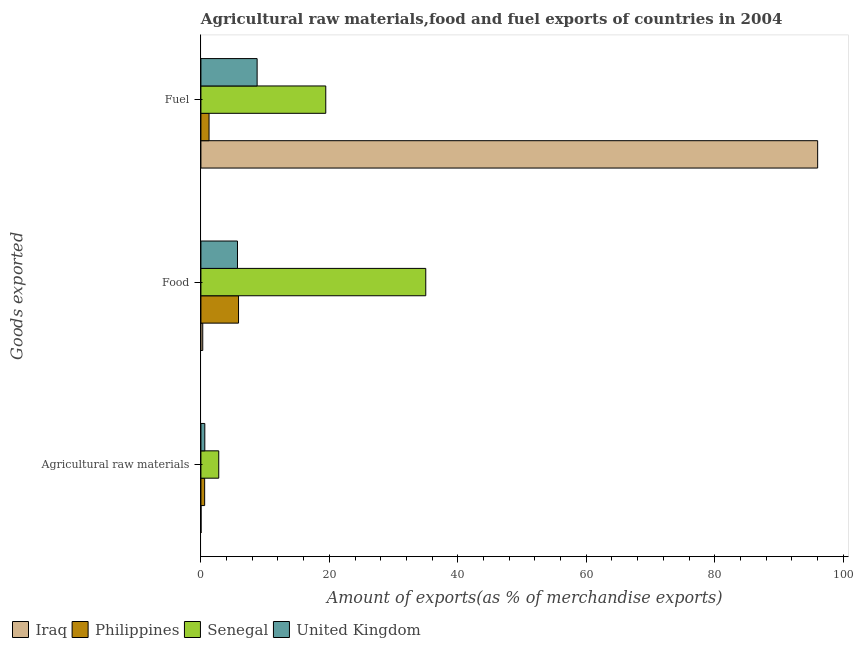How many different coloured bars are there?
Ensure brevity in your answer.  4. How many groups of bars are there?
Ensure brevity in your answer.  3. Are the number of bars per tick equal to the number of legend labels?
Your answer should be very brief. Yes. Are the number of bars on each tick of the Y-axis equal?
Offer a terse response. Yes. How many bars are there on the 3rd tick from the top?
Your answer should be very brief. 4. What is the label of the 1st group of bars from the top?
Your answer should be very brief. Fuel. What is the percentage of raw materials exports in Senegal?
Your answer should be compact. 2.78. Across all countries, what is the maximum percentage of fuel exports?
Keep it short and to the point. 96.03. Across all countries, what is the minimum percentage of raw materials exports?
Keep it short and to the point. 0.01. In which country was the percentage of fuel exports maximum?
Provide a succinct answer. Iraq. In which country was the percentage of food exports minimum?
Provide a succinct answer. Iraq. What is the total percentage of fuel exports in the graph?
Provide a succinct answer. 125.49. What is the difference between the percentage of food exports in Iraq and that in Philippines?
Provide a succinct answer. -5.57. What is the difference between the percentage of food exports in Senegal and the percentage of fuel exports in Iraq?
Ensure brevity in your answer.  -61.02. What is the average percentage of food exports per country?
Offer a very short reply. 11.71. What is the difference between the percentage of raw materials exports and percentage of food exports in Senegal?
Provide a succinct answer. -32.23. In how many countries, is the percentage of raw materials exports greater than 32 %?
Offer a very short reply. 0. What is the ratio of the percentage of raw materials exports in United Kingdom to that in Philippines?
Offer a terse response. 1.04. What is the difference between the highest and the second highest percentage of food exports?
Give a very brief answer. 29.15. What is the difference between the highest and the lowest percentage of raw materials exports?
Your answer should be very brief. 2.76. What does the 2nd bar from the top in Food represents?
Ensure brevity in your answer.  Senegal. Are all the bars in the graph horizontal?
Offer a very short reply. Yes. What is the difference between two consecutive major ticks on the X-axis?
Ensure brevity in your answer.  20. Are the values on the major ticks of X-axis written in scientific E-notation?
Offer a terse response. No. Does the graph contain any zero values?
Make the answer very short. No. Where does the legend appear in the graph?
Your response must be concise. Bottom left. How many legend labels are there?
Give a very brief answer. 4. What is the title of the graph?
Offer a very short reply. Agricultural raw materials,food and fuel exports of countries in 2004. Does "Puerto Rico" appear as one of the legend labels in the graph?
Offer a terse response. No. What is the label or title of the X-axis?
Ensure brevity in your answer.  Amount of exports(as % of merchandise exports). What is the label or title of the Y-axis?
Your answer should be compact. Goods exported. What is the Amount of exports(as % of merchandise exports) of Iraq in Agricultural raw materials?
Ensure brevity in your answer.  0.01. What is the Amount of exports(as % of merchandise exports) of Philippines in Agricultural raw materials?
Your response must be concise. 0.58. What is the Amount of exports(as % of merchandise exports) in Senegal in Agricultural raw materials?
Your answer should be compact. 2.78. What is the Amount of exports(as % of merchandise exports) in United Kingdom in Agricultural raw materials?
Provide a short and direct response. 0.61. What is the Amount of exports(as % of merchandise exports) of Iraq in Food?
Provide a succinct answer. 0.29. What is the Amount of exports(as % of merchandise exports) of Philippines in Food?
Give a very brief answer. 5.86. What is the Amount of exports(as % of merchandise exports) in Senegal in Food?
Offer a terse response. 35.01. What is the Amount of exports(as % of merchandise exports) of United Kingdom in Food?
Provide a succinct answer. 5.69. What is the Amount of exports(as % of merchandise exports) of Iraq in Fuel?
Ensure brevity in your answer.  96.03. What is the Amount of exports(as % of merchandise exports) of Philippines in Fuel?
Give a very brief answer. 1.26. What is the Amount of exports(as % of merchandise exports) in Senegal in Fuel?
Offer a very short reply. 19.44. What is the Amount of exports(as % of merchandise exports) in United Kingdom in Fuel?
Offer a terse response. 8.75. Across all Goods exported, what is the maximum Amount of exports(as % of merchandise exports) in Iraq?
Provide a succinct answer. 96.03. Across all Goods exported, what is the maximum Amount of exports(as % of merchandise exports) in Philippines?
Provide a succinct answer. 5.86. Across all Goods exported, what is the maximum Amount of exports(as % of merchandise exports) in Senegal?
Your response must be concise. 35.01. Across all Goods exported, what is the maximum Amount of exports(as % of merchandise exports) in United Kingdom?
Provide a succinct answer. 8.75. Across all Goods exported, what is the minimum Amount of exports(as % of merchandise exports) of Iraq?
Offer a very short reply. 0.01. Across all Goods exported, what is the minimum Amount of exports(as % of merchandise exports) of Philippines?
Make the answer very short. 0.58. Across all Goods exported, what is the minimum Amount of exports(as % of merchandise exports) of Senegal?
Offer a very short reply. 2.78. Across all Goods exported, what is the minimum Amount of exports(as % of merchandise exports) in United Kingdom?
Your answer should be compact. 0.61. What is the total Amount of exports(as % of merchandise exports) in Iraq in the graph?
Your answer should be very brief. 96.33. What is the total Amount of exports(as % of merchandise exports) of Philippines in the graph?
Provide a short and direct response. 7.7. What is the total Amount of exports(as % of merchandise exports) of Senegal in the graph?
Give a very brief answer. 57.23. What is the total Amount of exports(as % of merchandise exports) in United Kingdom in the graph?
Offer a terse response. 15.05. What is the difference between the Amount of exports(as % of merchandise exports) in Iraq in Agricultural raw materials and that in Food?
Offer a very short reply. -0.27. What is the difference between the Amount of exports(as % of merchandise exports) of Philippines in Agricultural raw materials and that in Food?
Offer a terse response. -5.27. What is the difference between the Amount of exports(as % of merchandise exports) in Senegal in Agricultural raw materials and that in Food?
Your answer should be very brief. -32.23. What is the difference between the Amount of exports(as % of merchandise exports) in United Kingdom in Agricultural raw materials and that in Food?
Your answer should be compact. -5.09. What is the difference between the Amount of exports(as % of merchandise exports) of Iraq in Agricultural raw materials and that in Fuel?
Provide a succinct answer. -96.02. What is the difference between the Amount of exports(as % of merchandise exports) of Philippines in Agricultural raw materials and that in Fuel?
Keep it short and to the point. -0.68. What is the difference between the Amount of exports(as % of merchandise exports) of Senegal in Agricultural raw materials and that in Fuel?
Give a very brief answer. -16.66. What is the difference between the Amount of exports(as % of merchandise exports) of United Kingdom in Agricultural raw materials and that in Fuel?
Provide a short and direct response. -8.15. What is the difference between the Amount of exports(as % of merchandise exports) of Iraq in Food and that in Fuel?
Provide a succinct answer. -95.75. What is the difference between the Amount of exports(as % of merchandise exports) of Philippines in Food and that in Fuel?
Provide a short and direct response. 4.59. What is the difference between the Amount of exports(as % of merchandise exports) in Senegal in Food and that in Fuel?
Keep it short and to the point. 15.57. What is the difference between the Amount of exports(as % of merchandise exports) of United Kingdom in Food and that in Fuel?
Ensure brevity in your answer.  -3.06. What is the difference between the Amount of exports(as % of merchandise exports) of Iraq in Agricultural raw materials and the Amount of exports(as % of merchandise exports) of Philippines in Food?
Provide a succinct answer. -5.84. What is the difference between the Amount of exports(as % of merchandise exports) of Iraq in Agricultural raw materials and the Amount of exports(as % of merchandise exports) of Senegal in Food?
Your answer should be very brief. -35. What is the difference between the Amount of exports(as % of merchandise exports) in Iraq in Agricultural raw materials and the Amount of exports(as % of merchandise exports) in United Kingdom in Food?
Your response must be concise. -5.68. What is the difference between the Amount of exports(as % of merchandise exports) of Philippines in Agricultural raw materials and the Amount of exports(as % of merchandise exports) of Senegal in Food?
Your answer should be very brief. -34.43. What is the difference between the Amount of exports(as % of merchandise exports) of Philippines in Agricultural raw materials and the Amount of exports(as % of merchandise exports) of United Kingdom in Food?
Your response must be concise. -5.11. What is the difference between the Amount of exports(as % of merchandise exports) of Senegal in Agricultural raw materials and the Amount of exports(as % of merchandise exports) of United Kingdom in Food?
Your response must be concise. -2.92. What is the difference between the Amount of exports(as % of merchandise exports) in Iraq in Agricultural raw materials and the Amount of exports(as % of merchandise exports) in Philippines in Fuel?
Provide a succinct answer. -1.25. What is the difference between the Amount of exports(as % of merchandise exports) of Iraq in Agricultural raw materials and the Amount of exports(as % of merchandise exports) of Senegal in Fuel?
Provide a short and direct response. -19.43. What is the difference between the Amount of exports(as % of merchandise exports) of Iraq in Agricultural raw materials and the Amount of exports(as % of merchandise exports) of United Kingdom in Fuel?
Make the answer very short. -8.74. What is the difference between the Amount of exports(as % of merchandise exports) in Philippines in Agricultural raw materials and the Amount of exports(as % of merchandise exports) in Senegal in Fuel?
Your answer should be very brief. -18.86. What is the difference between the Amount of exports(as % of merchandise exports) of Philippines in Agricultural raw materials and the Amount of exports(as % of merchandise exports) of United Kingdom in Fuel?
Offer a very short reply. -8.17. What is the difference between the Amount of exports(as % of merchandise exports) of Senegal in Agricultural raw materials and the Amount of exports(as % of merchandise exports) of United Kingdom in Fuel?
Your response must be concise. -5.98. What is the difference between the Amount of exports(as % of merchandise exports) of Iraq in Food and the Amount of exports(as % of merchandise exports) of Philippines in Fuel?
Keep it short and to the point. -0.98. What is the difference between the Amount of exports(as % of merchandise exports) in Iraq in Food and the Amount of exports(as % of merchandise exports) in Senegal in Fuel?
Your answer should be compact. -19.16. What is the difference between the Amount of exports(as % of merchandise exports) in Iraq in Food and the Amount of exports(as % of merchandise exports) in United Kingdom in Fuel?
Give a very brief answer. -8.47. What is the difference between the Amount of exports(as % of merchandise exports) of Philippines in Food and the Amount of exports(as % of merchandise exports) of Senegal in Fuel?
Offer a very short reply. -13.58. What is the difference between the Amount of exports(as % of merchandise exports) in Philippines in Food and the Amount of exports(as % of merchandise exports) in United Kingdom in Fuel?
Your answer should be very brief. -2.9. What is the difference between the Amount of exports(as % of merchandise exports) in Senegal in Food and the Amount of exports(as % of merchandise exports) in United Kingdom in Fuel?
Make the answer very short. 26.26. What is the average Amount of exports(as % of merchandise exports) of Iraq per Goods exported?
Ensure brevity in your answer.  32.11. What is the average Amount of exports(as % of merchandise exports) in Philippines per Goods exported?
Your answer should be very brief. 2.57. What is the average Amount of exports(as % of merchandise exports) in Senegal per Goods exported?
Your answer should be very brief. 19.08. What is the average Amount of exports(as % of merchandise exports) of United Kingdom per Goods exported?
Ensure brevity in your answer.  5.02. What is the difference between the Amount of exports(as % of merchandise exports) in Iraq and Amount of exports(as % of merchandise exports) in Philippines in Agricultural raw materials?
Ensure brevity in your answer.  -0.57. What is the difference between the Amount of exports(as % of merchandise exports) of Iraq and Amount of exports(as % of merchandise exports) of Senegal in Agricultural raw materials?
Your answer should be very brief. -2.76. What is the difference between the Amount of exports(as % of merchandise exports) of Iraq and Amount of exports(as % of merchandise exports) of United Kingdom in Agricultural raw materials?
Your response must be concise. -0.59. What is the difference between the Amount of exports(as % of merchandise exports) of Philippines and Amount of exports(as % of merchandise exports) of Senegal in Agricultural raw materials?
Make the answer very short. -2.19. What is the difference between the Amount of exports(as % of merchandise exports) in Philippines and Amount of exports(as % of merchandise exports) in United Kingdom in Agricultural raw materials?
Offer a terse response. -0.02. What is the difference between the Amount of exports(as % of merchandise exports) of Senegal and Amount of exports(as % of merchandise exports) of United Kingdom in Agricultural raw materials?
Your answer should be compact. 2.17. What is the difference between the Amount of exports(as % of merchandise exports) of Iraq and Amount of exports(as % of merchandise exports) of Philippines in Food?
Offer a terse response. -5.57. What is the difference between the Amount of exports(as % of merchandise exports) in Iraq and Amount of exports(as % of merchandise exports) in Senegal in Food?
Offer a terse response. -34.73. What is the difference between the Amount of exports(as % of merchandise exports) of Iraq and Amount of exports(as % of merchandise exports) of United Kingdom in Food?
Ensure brevity in your answer.  -5.41. What is the difference between the Amount of exports(as % of merchandise exports) in Philippines and Amount of exports(as % of merchandise exports) in Senegal in Food?
Offer a terse response. -29.15. What is the difference between the Amount of exports(as % of merchandise exports) of Philippines and Amount of exports(as % of merchandise exports) of United Kingdom in Food?
Give a very brief answer. 0.16. What is the difference between the Amount of exports(as % of merchandise exports) in Senegal and Amount of exports(as % of merchandise exports) in United Kingdom in Food?
Offer a terse response. 29.32. What is the difference between the Amount of exports(as % of merchandise exports) in Iraq and Amount of exports(as % of merchandise exports) in Philippines in Fuel?
Give a very brief answer. 94.77. What is the difference between the Amount of exports(as % of merchandise exports) in Iraq and Amount of exports(as % of merchandise exports) in Senegal in Fuel?
Your response must be concise. 76.59. What is the difference between the Amount of exports(as % of merchandise exports) in Iraq and Amount of exports(as % of merchandise exports) in United Kingdom in Fuel?
Your answer should be very brief. 87.28. What is the difference between the Amount of exports(as % of merchandise exports) in Philippines and Amount of exports(as % of merchandise exports) in Senegal in Fuel?
Provide a succinct answer. -18.18. What is the difference between the Amount of exports(as % of merchandise exports) in Philippines and Amount of exports(as % of merchandise exports) in United Kingdom in Fuel?
Keep it short and to the point. -7.49. What is the difference between the Amount of exports(as % of merchandise exports) in Senegal and Amount of exports(as % of merchandise exports) in United Kingdom in Fuel?
Offer a terse response. 10.69. What is the ratio of the Amount of exports(as % of merchandise exports) in Iraq in Agricultural raw materials to that in Food?
Make the answer very short. 0.05. What is the ratio of the Amount of exports(as % of merchandise exports) of Philippines in Agricultural raw materials to that in Food?
Your answer should be compact. 0.1. What is the ratio of the Amount of exports(as % of merchandise exports) of Senegal in Agricultural raw materials to that in Food?
Keep it short and to the point. 0.08. What is the ratio of the Amount of exports(as % of merchandise exports) of United Kingdom in Agricultural raw materials to that in Food?
Provide a short and direct response. 0.11. What is the ratio of the Amount of exports(as % of merchandise exports) in Philippines in Agricultural raw materials to that in Fuel?
Make the answer very short. 0.46. What is the ratio of the Amount of exports(as % of merchandise exports) of Senegal in Agricultural raw materials to that in Fuel?
Your answer should be compact. 0.14. What is the ratio of the Amount of exports(as % of merchandise exports) in United Kingdom in Agricultural raw materials to that in Fuel?
Your response must be concise. 0.07. What is the ratio of the Amount of exports(as % of merchandise exports) of Iraq in Food to that in Fuel?
Your answer should be very brief. 0. What is the ratio of the Amount of exports(as % of merchandise exports) of Philippines in Food to that in Fuel?
Your response must be concise. 4.63. What is the ratio of the Amount of exports(as % of merchandise exports) of Senegal in Food to that in Fuel?
Offer a terse response. 1.8. What is the ratio of the Amount of exports(as % of merchandise exports) in United Kingdom in Food to that in Fuel?
Keep it short and to the point. 0.65. What is the difference between the highest and the second highest Amount of exports(as % of merchandise exports) of Iraq?
Your answer should be very brief. 95.75. What is the difference between the highest and the second highest Amount of exports(as % of merchandise exports) in Philippines?
Your answer should be compact. 4.59. What is the difference between the highest and the second highest Amount of exports(as % of merchandise exports) in Senegal?
Make the answer very short. 15.57. What is the difference between the highest and the second highest Amount of exports(as % of merchandise exports) of United Kingdom?
Keep it short and to the point. 3.06. What is the difference between the highest and the lowest Amount of exports(as % of merchandise exports) of Iraq?
Provide a succinct answer. 96.02. What is the difference between the highest and the lowest Amount of exports(as % of merchandise exports) of Philippines?
Offer a terse response. 5.27. What is the difference between the highest and the lowest Amount of exports(as % of merchandise exports) of Senegal?
Give a very brief answer. 32.23. What is the difference between the highest and the lowest Amount of exports(as % of merchandise exports) of United Kingdom?
Ensure brevity in your answer.  8.15. 